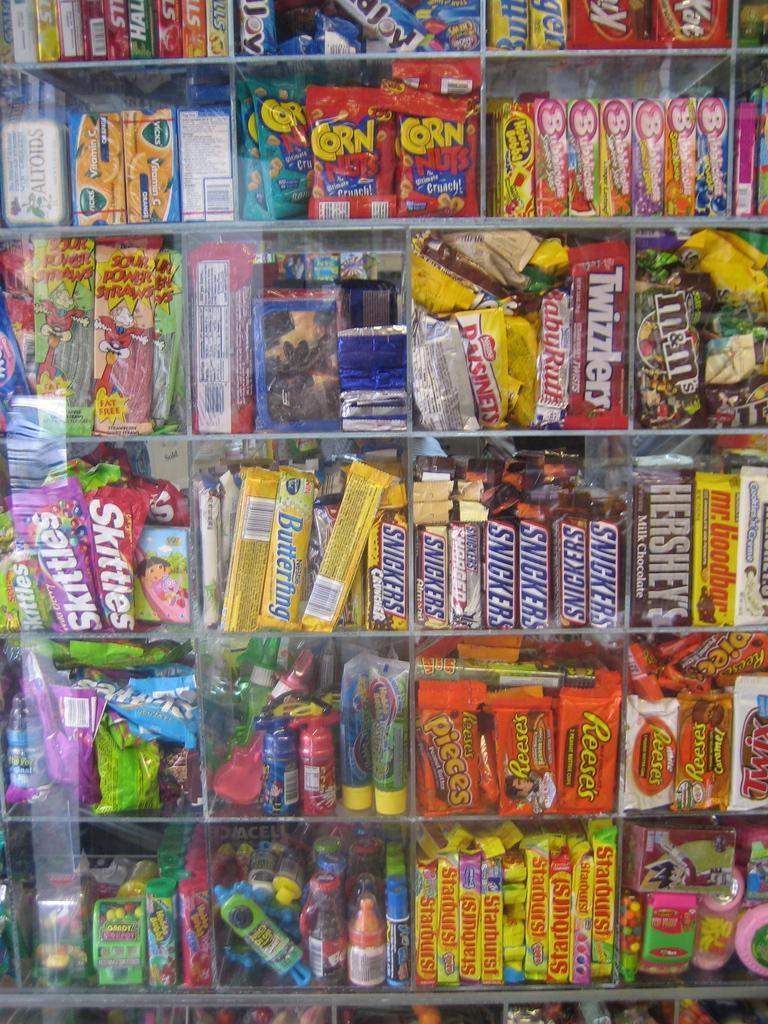<image>
Describe the image concisely. A stand full of colourful candy bars such as Snickers, Skittles, Reeses, M&M's and many more. 